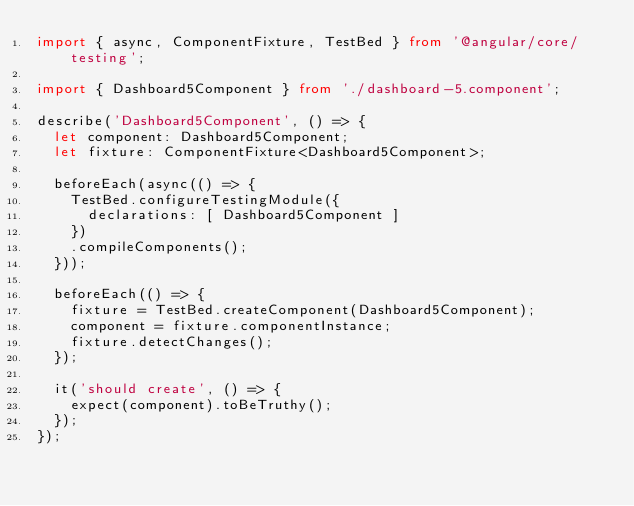<code> <loc_0><loc_0><loc_500><loc_500><_TypeScript_>import { async, ComponentFixture, TestBed } from '@angular/core/testing';

import { Dashboard5Component } from './dashboard-5.component';

describe('Dashboard5Component', () => {
  let component: Dashboard5Component;
  let fixture: ComponentFixture<Dashboard5Component>;

  beforeEach(async(() => {
    TestBed.configureTestingModule({
      declarations: [ Dashboard5Component ]
    })
    .compileComponents();
  }));

  beforeEach(() => {
    fixture = TestBed.createComponent(Dashboard5Component);
    component = fixture.componentInstance;
    fixture.detectChanges();
  });

  it('should create', () => {
    expect(component).toBeTruthy();
  });
});
</code> 